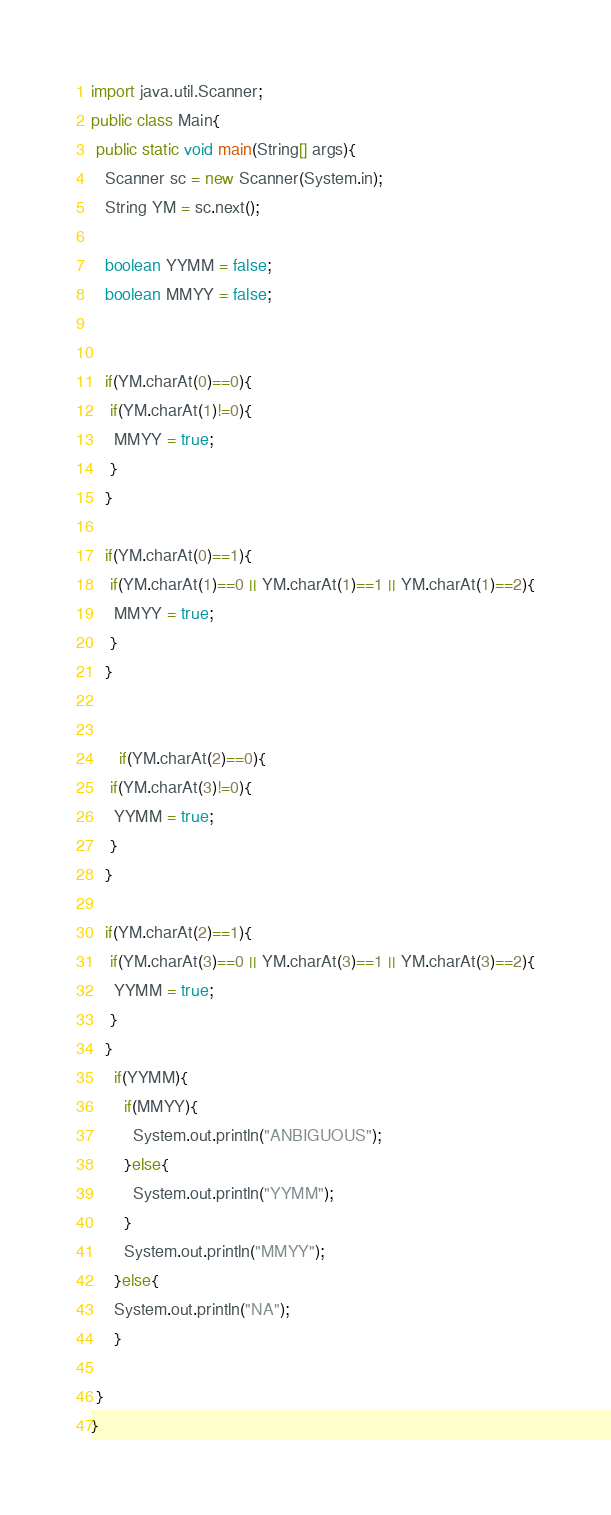Convert code to text. <code><loc_0><loc_0><loc_500><loc_500><_Java_>import java.util.Scanner;
public class Main{
 public static void main(String[] args){
   Scanner sc = new Scanner(System.in);
   String YM = sc.next();
   
   boolean YYMM = false;
   boolean MMYY = false;
   
   
   if(YM.charAt(0)==0){
    if(YM.charAt(1)!=0){
     MMYY = true;
    }
   }
     
   if(YM.charAt(0)==1){
    if(YM.charAt(1)==0 || YM.charAt(1)==1 || YM.charAt(1)==2){
     MMYY = true;
    }     
   }
   
     
      if(YM.charAt(2)==0){
    if(YM.charAt(3)!=0){
     YYMM = true;
    }
   }
     
   if(YM.charAt(2)==1){
    if(YM.charAt(3)==0 || YM.charAt(3)==1 || YM.charAt(3)==2){
     YYMM = true;
    }     
   }
     if(YYMM){
       if(MMYY){
         System.out.println("ANBIGUOUS");
       }else{
         System.out.println("YYMM");
       }
       System.out.println("MMYY");
     }else{
     System.out.println("NA");
     }

 }
}</code> 